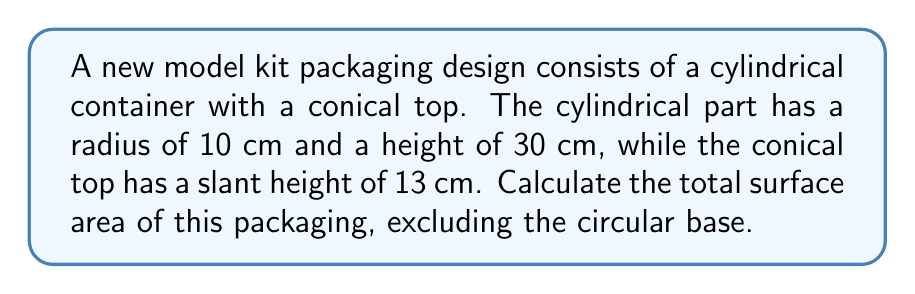Provide a solution to this math problem. Let's break this down step-by-step:

1) The surface area consists of three parts:
   a) Lateral surface area of the cylinder
   b) Circular top of the cylinder (which is also the base of the cone)
   c) Lateral surface area of the cone

2) Lateral surface area of the cylinder:
   $$ A_{cylinder} = 2\pi rh $$
   where $r$ is the radius and $h$ is the height
   $$ A_{cylinder} = 2\pi (10)(30) = 600\pi \text{ cm}^2 $$

3) Area of the circular top:
   $$ A_{circle} = \pi r^2 = \pi (10)^2 = 100\pi \text{ cm}^2 $$

4) For the cone, we need to find its radius. We can do this using the Pythagorean theorem:
   $$ r^2 + h^2 = s^2 $$
   where $s$ is the slant height and $h$ is the height of the cone
   $$ 10^2 + h^2 = 13^2 $$
   $$ h^2 = 13^2 - 10^2 = 169 - 100 = 69 $$
   $$ h = \sqrt{69} \approx 8.31 \text{ cm} $$

5) Lateral surface area of the cone:
   $$ A_{cone} = \pi rs = \pi (10)(13) = 130\pi \text{ cm}^2 $$

6) Total surface area:
   $$ A_{total} = A_{cylinder} + A_{circle} + A_{cone} $$
   $$ A_{total} = 600\pi + 100\pi + 130\pi = 830\pi \text{ cm}^2 $$
Answer: $830\pi \text{ cm}^2$ 